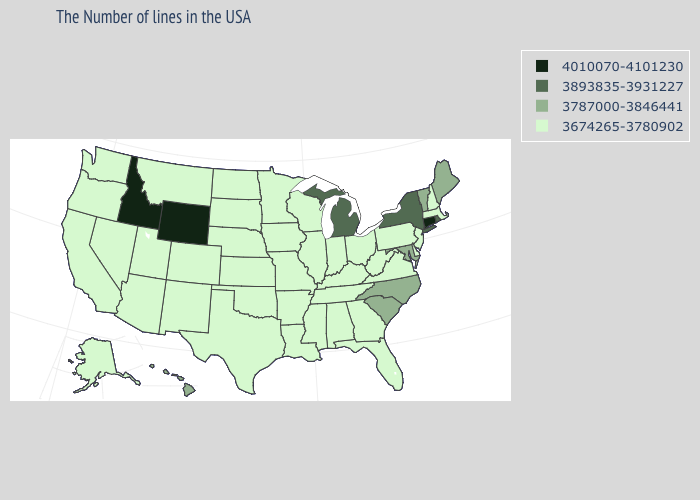What is the value of Maine?
Short answer required. 3787000-3846441. Name the states that have a value in the range 3674265-3780902?
Short answer required. Massachusetts, New Hampshire, New Jersey, Delaware, Pennsylvania, Virginia, West Virginia, Ohio, Florida, Georgia, Kentucky, Indiana, Alabama, Tennessee, Wisconsin, Illinois, Mississippi, Louisiana, Missouri, Arkansas, Minnesota, Iowa, Kansas, Nebraska, Oklahoma, Texas, South Dakota, North Dakota, Colorado, New Mexico, Utah, Montana, Arizona, Nevada, California, Washington, Oregon, Alaska. Among the states that border Kansas , which have the lowest value?
Concise answer only. Missouri, Nebraska, Oklahoma, Colorado. What is the value of Florida?
Answer briefly. 3674265-3780902. Among the states that border Indiana , which have the highest value?
Keep it brief. Michigan. Name the states that have a value in the range 3674265-3780902?
Give a very brief answer. Massachusetts, New Hampshire, New Jersey, Delaware, Pennsylvania, Virginia, West Virginia, Ohio, Florida, Georgia, Kentucky, Indiana, Alabama, Tennessee, Wisconsin, Illinois, Mississippi, Louisiana, Missouri, Arkansas, Minnesota, Iowa, Kansas, Nebraska, Oklahoma, Texas, South Dakota, North Dakota, Colorado, New Mexico, Utah, Montana, Arizona, Nevada, California, Washington, Oregon, Alaska. Does Minnesota have a higher value than Kentucky?
Short answer required. No. Which states have the lowest value in the USA?
Quick response, please. Massachusetts, New Hampshire, New Jersey, Delaware, Pennsylvania, Virginia, West Virginia, Ohio, Florida, Georgia, Kentucky, Indiana, Alabama, Tennessee, Wisconsin, Illinois, Mississippi, Louisiana, Missouri, Arkansas, Minnesota, Iowa, Kansas, Nebraska, Oklahoma, Texas, South Dakota, North Dakota, Colorado, New Mexico, Utah, Montana, Arizona, Nevada, California, Washington, Oregon, Alaska. Name the states that have a value in the range 3787000-3846441?
Concise answer only. Maine, Vermont, Maryland, North Carolina, South Carolina, Hawaii. What is the value of Wisconsin?
Give a very brief answer. 3674265-3780902. What is the highest value in the USA?
Write a very short answer. 4010070-4101230. How many symbols are there in the legend?
Write a very short answer. 4. Name the states that have a value in the range 3674265-3780902?
Quick response, please. Massachusetts, New Hampshire, New Jersey, Delaware, Pennsylvania, Virginia, West Virginia, Ohio, Florida, Georgia, Kentucky, Indiana, Alabama, Tennessee, Wisconsin, Illinois, Mississippi, Louisiana, Missouri, Arkansas, Minnesota, Iowa, Kansas, Nebraska, Oklahoma, Texas, South Dakota, North Dakota, Colorado, New Mexico, Utah, Montana, Arizona, Nevada, California, Washington, Oregon, Alaska. Name the states that have a value in the range 3674265-3780902?
Answer briefly. Massachusetts, New Hampshire, New Jersey, Delaware, Pennsylvania, Virginia, West Virginia, Ohio, Florida, Georgia, Kentucky, Indiana, Alabama, Tennessee, Wisconsin, Illinois, Mississippi, Louisiana, Missouri, Arkansas, Minnesota, Iowa, Kansas, Nebraska, Oklahoma, Texas, South Dakota, North Dakota, Colorado, New Mexico, Utah, Montana, Arizona, Nevada, California, Washington, Oregon, Alaska. Does Louisiana have the highest value in the USA?
Quick response, please. No. 